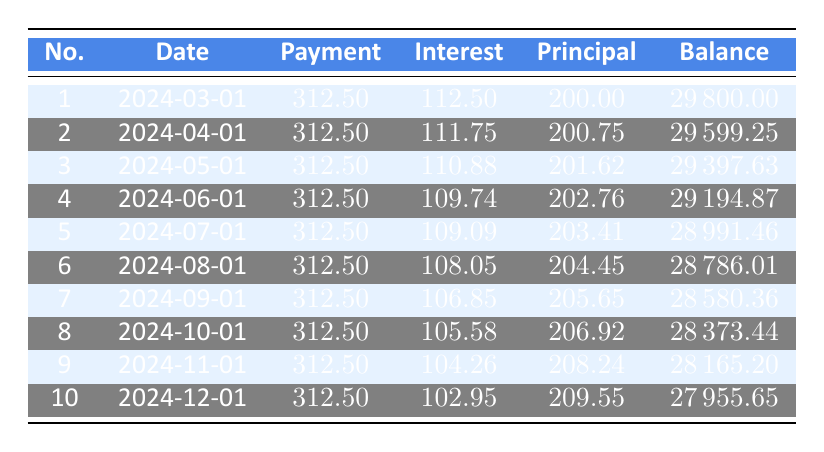What is the total payment amount for the first 10 months? Each payment is 312.50, and there are 10 payments. Therefore, the total payment amount is calculated as 312.50 * 10 = 3125.00.
Answer: 3125.00 What is the interest payment for the second payment? The interest payment for the second payment is clearly stated in the table as 111.75.
Answer: 111.75 Is the principal payment increasing over the first 10 payments? By observing the principal payments in the table, they start at 200.00 and increase to 209.55, confirming that it increases with each successive payment.
Answer: Yes What is the remaining balance after the 5th payment? The remaining balance after the 5th payment is recorded in the table as 28991.46.
Answer: 28991.46 What is the average principal payment over the first 10 payments? To find the average, we first sum the principal payments: 200.00 + 200.75 + 201.62 + 202.76 + 203.41 + 204.45 + 205.65 + 206.92 + 208.24 + 209.55 = 2033.40. Then, we divide by the number of payments (10), resulting in an average of 203.34.
Answer: 203.34 How much is the interest payment for the 10th payment compared to the first payment? The interest payment for the 10th payment is 102.95, while for the first payment it is 112.50. Comparing these two amounts shows that the 10th payment has 9.55 less in interest payment.
Answer: 102.95 What is the difference in the remaining balance between the first and the last payment? The remaining balance after the first payment is 29800.00 and after the last payment is 27955.65. The difference is calculated as 29800.00 - 27955.65 = 844.35.
Answer: 844.35 Is there any payment where the principal payment is less than 200? Reviewing the table shows that all principal payments are greater than 200, starting at 200.00 and increasing thereafter.
Answer: No What is the total interest payment for the first five payments? Summing the interest payments for the first five payments gives us: 112.50 + 111.75 + 110.88 + 109.74 + 109.09 = 553.96.
Answer: 553.96 